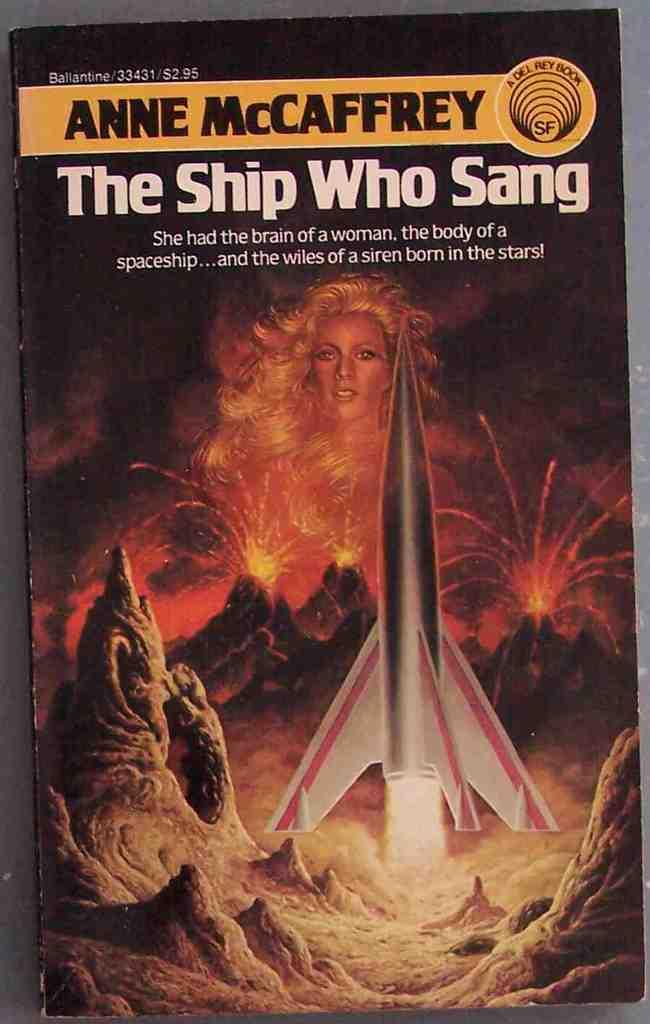Who is the author of this book?
Offer a very short reply. Anne mccaffrey. What is the title of this book?
Offer a very short reply. The ship who sang. 